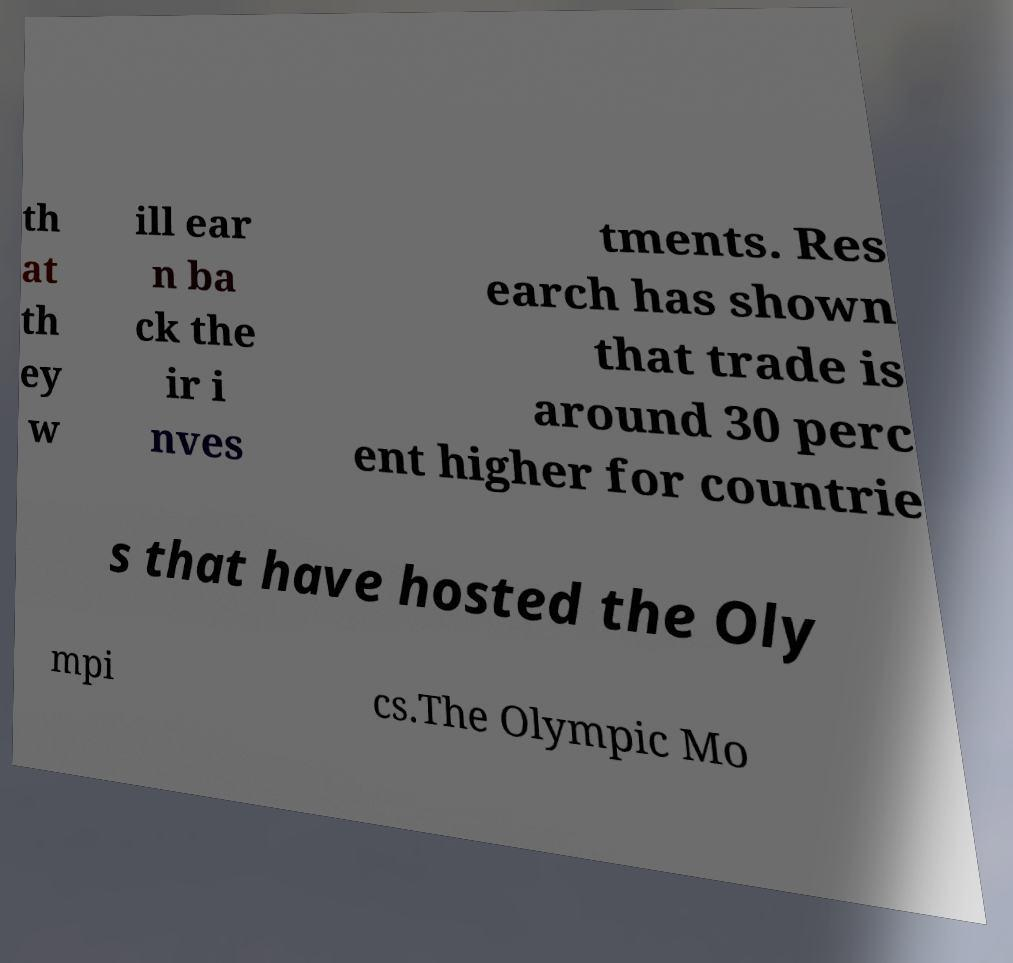For documentation purposes, I need the text within this image transcribed. Could you provide that? th at th ey w ill ear n ba ck the ir i nves tments. Res earch has shown that trade is around 30 perc ent higher for countrie s that have hosted the Oly mpi cs.The Olympic Mo 